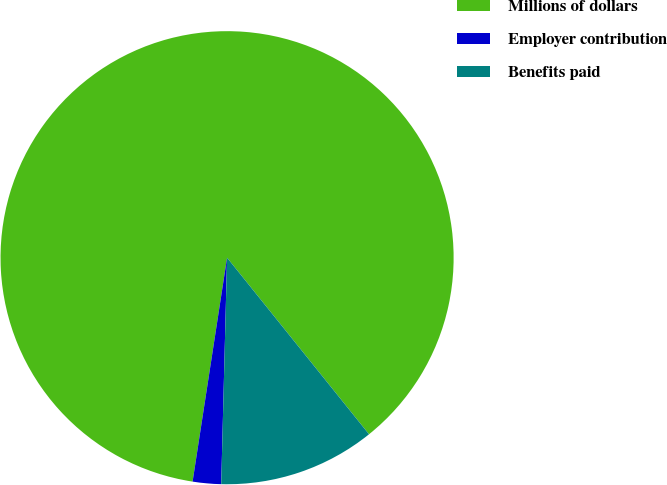<chart> <loc_0><loc_0><loc_500><loc_500><pie_chart><fcel>Millions of dollars<fcel>Employer contribution<fcel>Benefits paid<nl><fcel>86.79%<fcel>2.02%<fcel>11.19%<nl></chart> 